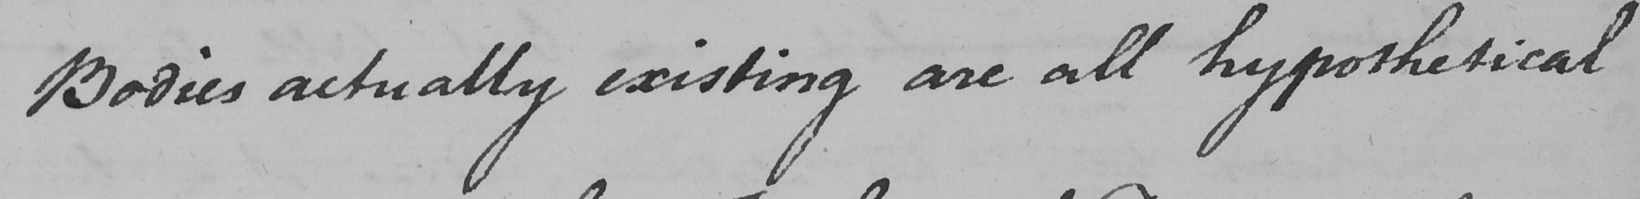What text is written in this handwritten line? Bodies actually existing are all hypothetical 